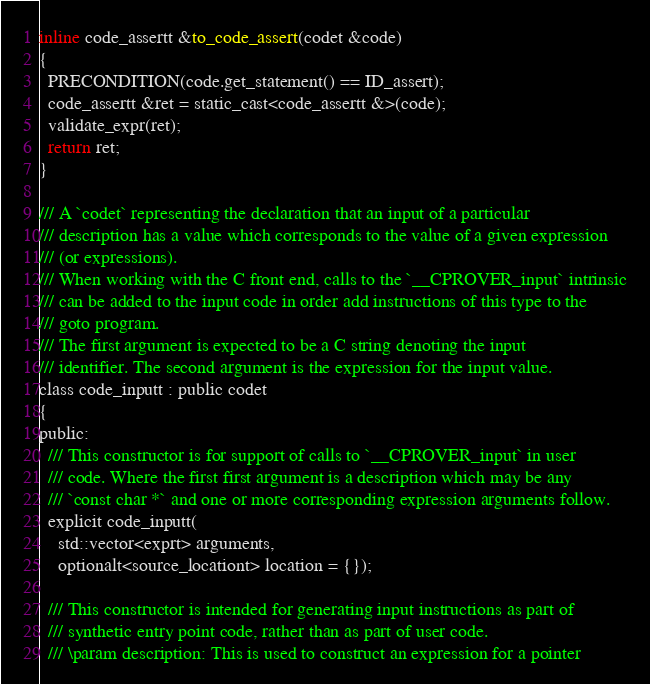Convert code to text. <code><loc_0><loc_0><loc_500><loc_500><_C_>inline code_assertt &to_code_assert(codet &code)
{
  PRECONDITION(code.get_statement() == ID_assert);
  code_assertt &ret = static_cast<code_assertt &>(code);
  validate_expr(ret);
  return ret;
}

/// A `codet` representing the declaration that an input of a particular
/// description has a value which corresponds to the value of a given expression
/// (or expressions).
/// When working with the C front end, calls to the `__CPROVER_input` intrinsic
/// can be added to the input code in order add instructions of this type to the
/// goto program.
/// The first argument is expected to be a C string denoting the input
/// identifier. The second argument is the expression for the input value.
class code_inputt : public codet
{
public:
  /// This constructor is for support of calls to `__CPROVER_input` in user
  /// code. Where the first first argument is a description which may be any
  /// `const char *` and one or more corresponding expression arguments follow.
  explicit code_inputt(
    std::vector<exprt> arguments,
    optionalt<source_locationt> location = {});

  /// This constructor is intended for generating input instructions as part of
  /// synthetic entry point code, rather than as part of user code.
  /// \param description: This is used to construct an expression for a pointer</code> 